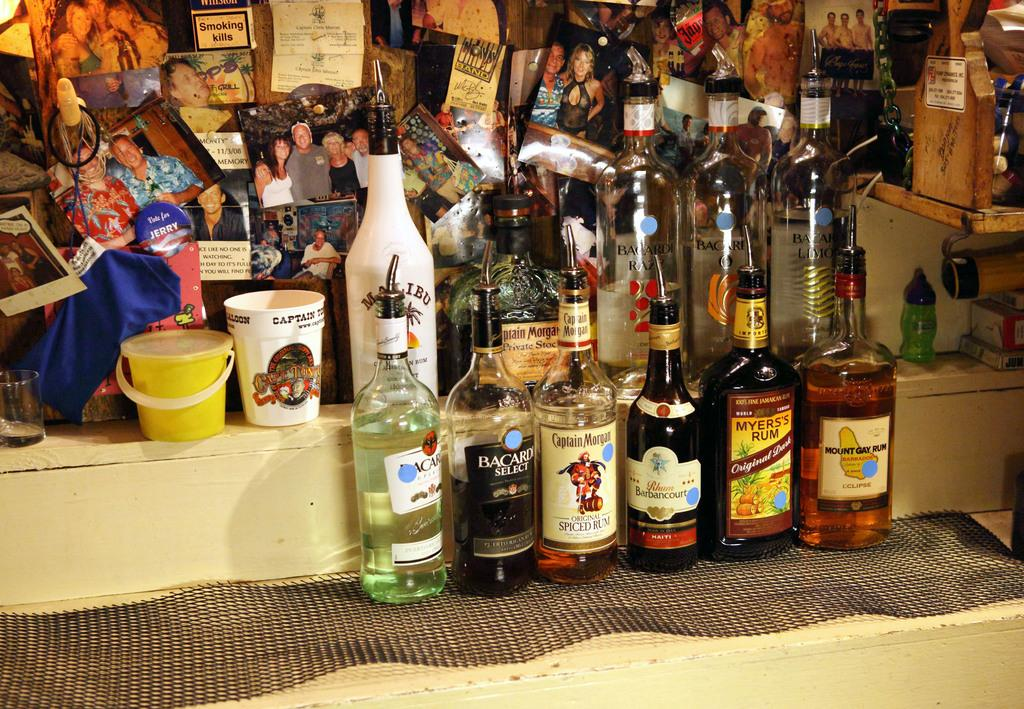What types of objects are present in the image? There are different types of bottles and photo frames in the image. How are the bottles and photo frames arranged in the image? The bottles and photo frames are placed together. What type of bridge can be seen in the image? There is no bridge present in the image; it features different types of bottles and photo frames. What color is the flag in the image? There is no flag present in the image. 